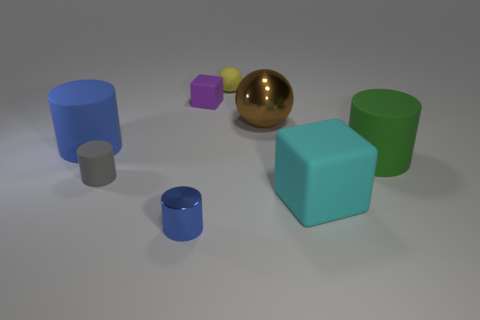Subtract all big green cylinders. How many cylinders are left? 3 Subtract all blue blocks. How many blue cylinders are left? 2 Subtract 1 spheres. How many spheres are left? 1 Subtract all blue cylinders. How many cylinders are left? 2 Add 1 tiny gray rubber cylinders. How many objects exist? 9 Subtract all cubes. How many objects are left? 6 Add 8 small cubes. How many small cubes are left? 9 Add 5 tiny purple rubber cylinders. How many tiny purple rubber cylinders exist? 5 Subtract 1 gray cylinders. How many objects are left? 7 Subtract all green cylinders. Subtract all purple blocks. How many cylinders are left? 3 